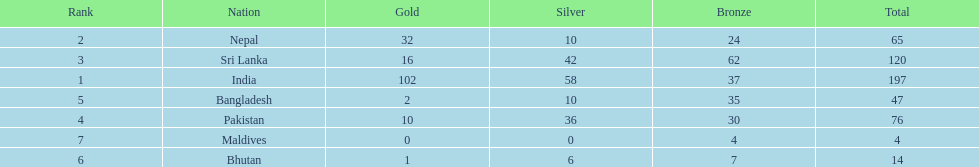How many gold medals were awarded between all 7 nations? 163. 